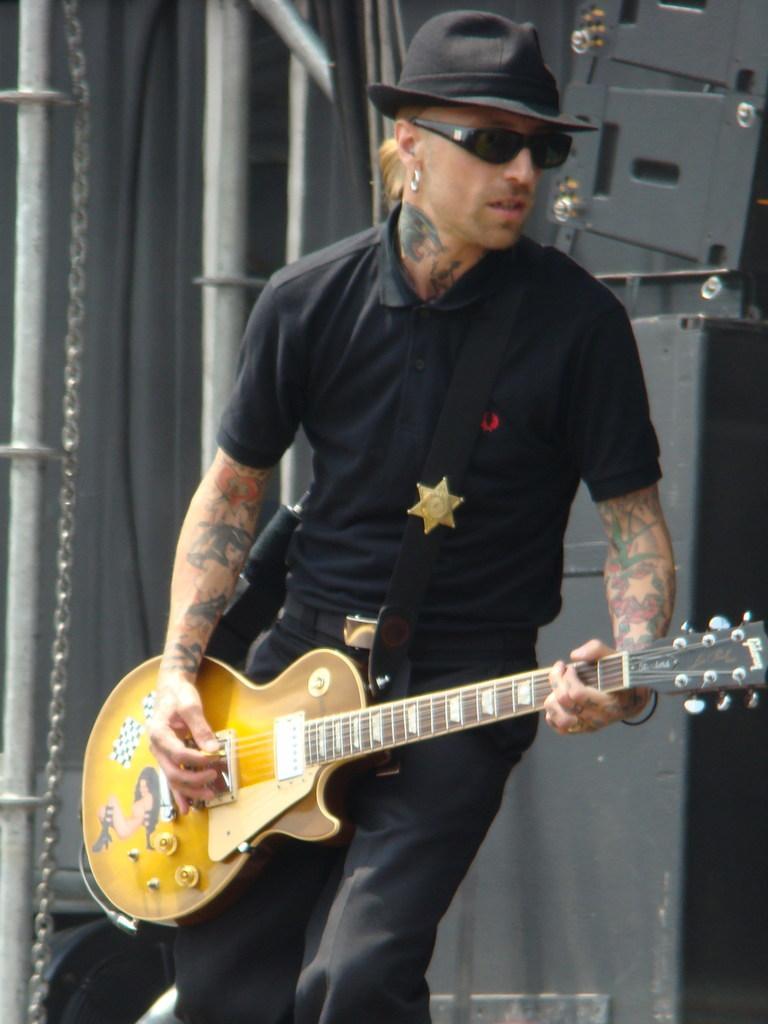Could you give a brief overview of what you see in this image? In this picture we can see a man playing a guitar, man wore a black color t-shirt, a black color pants and he wore a black color hat and in the background we can see some chains and rod. 